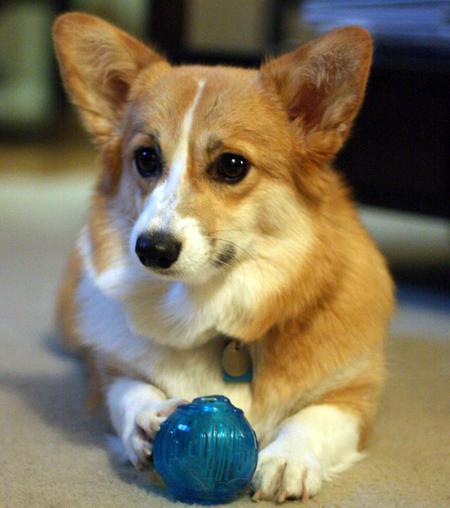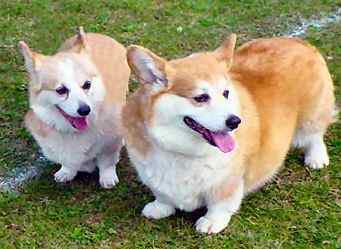The first image is the image on the left, the second image is the image on the right. Analyze the images presented: Is the assertion "There are at most two corgis." valid? Answer yes or no. No. The first image is the image on the left, the second image is the image on the right. For the images displayed, is the sentence "One of the images shows two corgis in close proximity to each other." factually correct? Answer yes or no. Yes. 